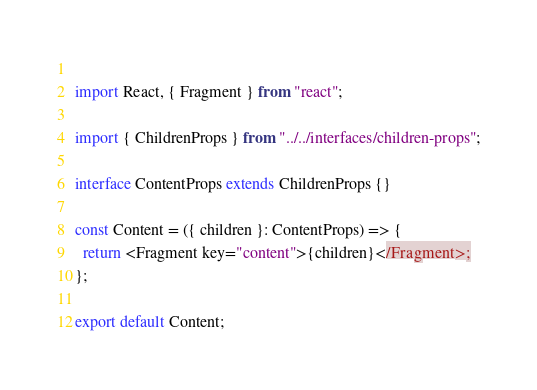Convert code to text. <code><loc_0><loc_0><loc_500><loc_500><_TypeScript_>  
import React, { Fragment } from "react";

import { ChildrenProps } from "../../interfaces/children-props";

interface ContentProps extends ChildrenProps {}

const Content = ({ children }: ContentProps) => {
  return <Fragment key="content">{children}</Fragment>;
};

export default Content;
</code> 